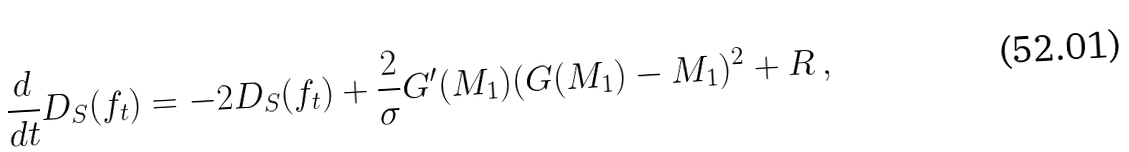<formula> <loc_0><loc_0><loc_500><loc_500>\frac { d } { d t } D _ { S } ( f _ { t } ) = - 2 D _ { S } ( f _ { t } ) + \frac { 2 } { \sigma } G ^ { \prime } ( M _ { 1 } ) ( G ( M _ { 1 } ) - M _ { 1 } ) ^ { 2 } + R \, ,</formula> 